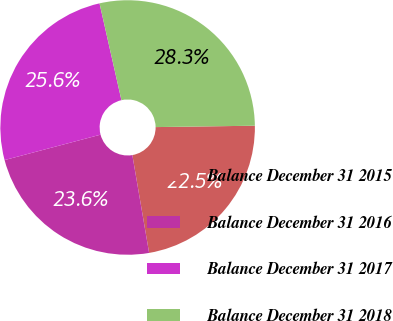Convert chart. <chart><loc_0><loc_0><loc_500><loc_500><pie_chart><fcel>Balance December 31 2015<fcel>Balance December 31 2016<fcel>Balance December 31 2017<fcel>Balance December 31 2018<nl><fcel>22.52%<fcel>23.58%<fcel>25.58%<fcel>28.32%<nl></chart> 